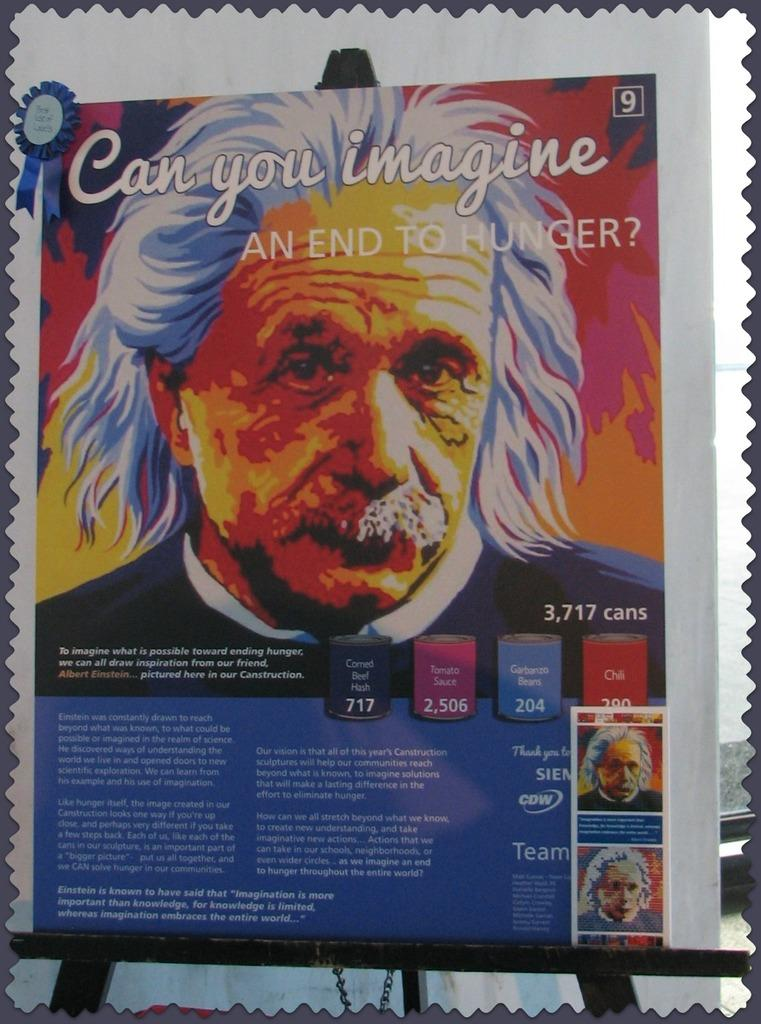What is the main subject in the image? There is a hoarding in the image. What is featured on the hoarding? The hoarding contains text and images of people. What type of comparison is being made between the people in the images on the hoarding? There is no comparison being made between the people in the images on the hoarding; the images simply depict people. What type of work are the people in the images on the hoarding performing? There is no indication of the type of work the people in the images on the hoarding are performing, as the images only depict people and not their actions or professions. 